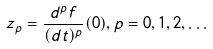<formula> <loc_0><loc_0><loc_500><loc_500>z _ { p } = \frac { d ^ { p } f } { ( d t ) ^ { p } } ( 0 ) , p = 0 , 1 , 2 , \dots</formula> 